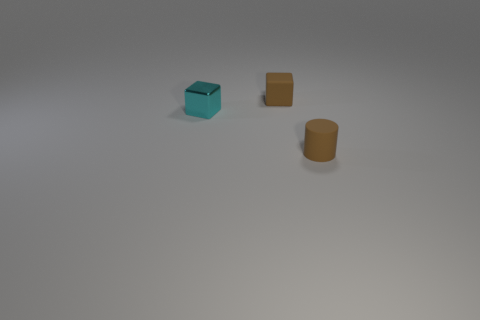If these objects were part of a larger set, what kind of set do you think that might be? If these objects are part of a larger set, it could potentially be a set of desk organizers or office supplies, given their potential utility in holding and organizing small items. Alternatively, they could be educational aids for teaching geometry and spatial concepts, due to their clear and distinct shapes. 